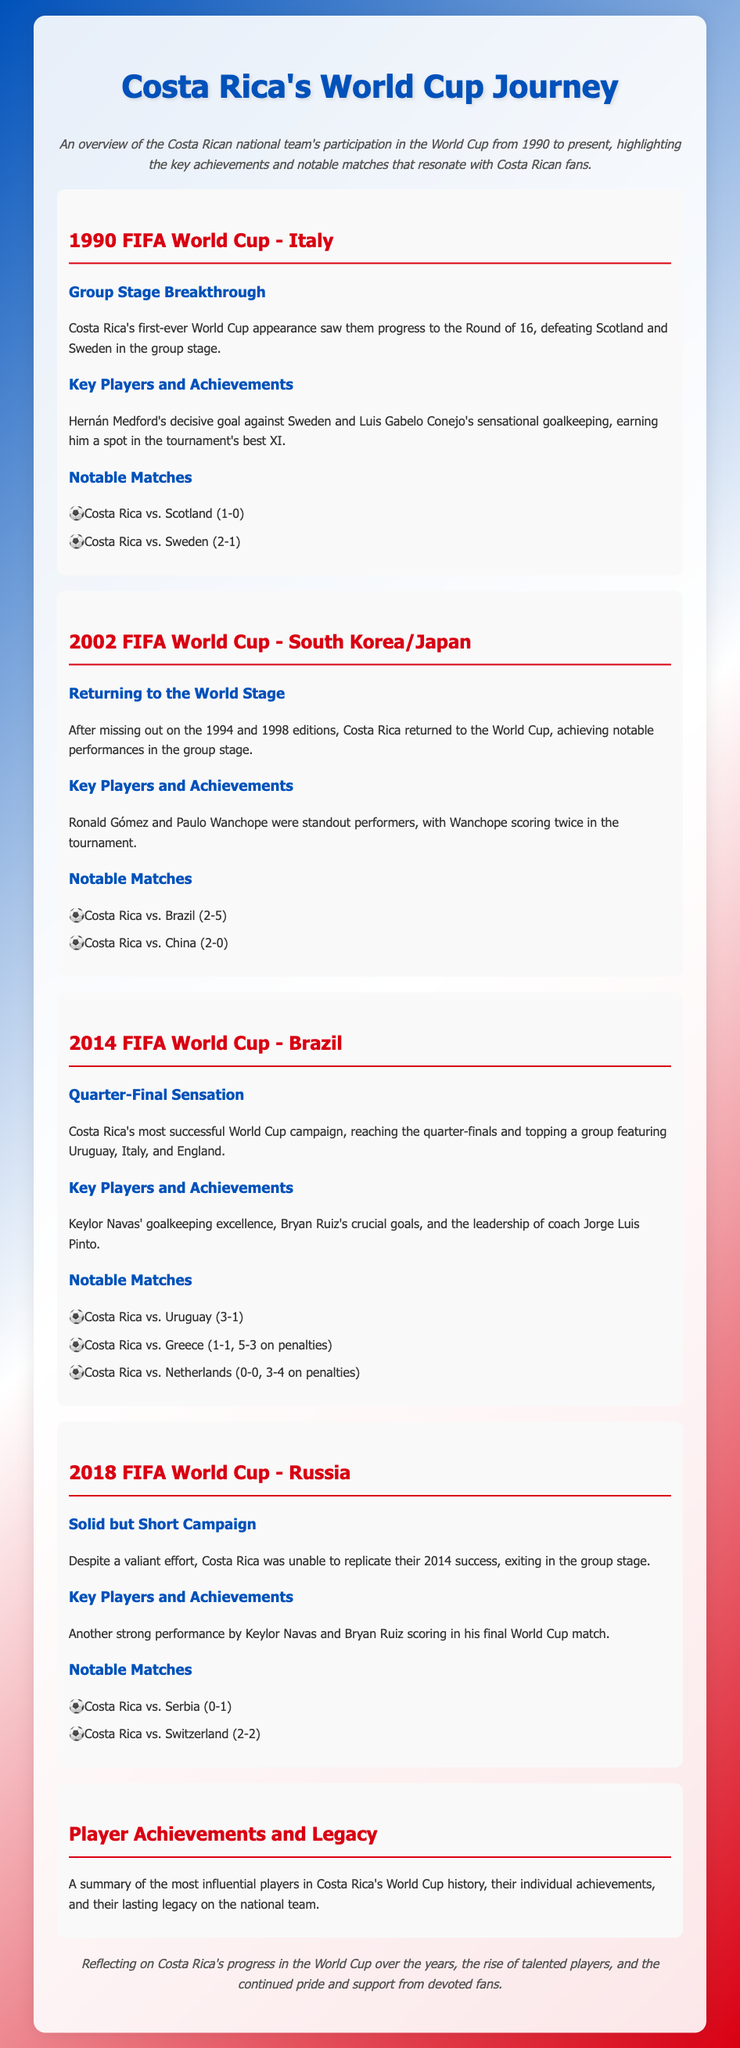What year was Costa Rica's first World Cup appearance? The document states that Costa Rica's first World Cup appearance was in 1990.
Answer: 1990 Who scored the decisive goal against Sweden in 1990? The document names Hernán Medford as the player who scored the decisive goal against Sweden.
Answer: Hernán Medford Which goalkeeper was recognized in the 1990 FIFA World Cup best XI? The document highlights Luis Gabelo Conejo's performances, earning him a spot in the tournament's best XI.
Answer: Luis Gabelo Conejo How many goals did Paulo Wanchope score in the 2002 tournament? The document indicates that Paulo Wanchope scored twice in the tournament.
Answer: Two What was the outcome of the match between Costa Rica and Uruguay in 2014? The document states that Costa Rica won the match against Uruguay with a score of 3-1.
Answer: 3-1 Which player scored in his final World Cup match in 2018? The document mentions Bryan Ruiz scoring in his final World Cup match.
Answer: Bryan Ruiz What significant achievement did Costa Rica reach in the 2014 World Cup? It states that Costa Rica reached the quarter-finals in their most successful World Cup campaign.
Answer: Quarter-finals How many notable matches are listed for the 2014 FIFA World Cup? The document lists three notable matches for the 2014 FIFA World Cup campaign.
Answer: Three What does the final section of the document summarize? The document mentions summarizing influential players' achievements and their legacy on the national team.
Answer: Influential players' achievements and legacy 